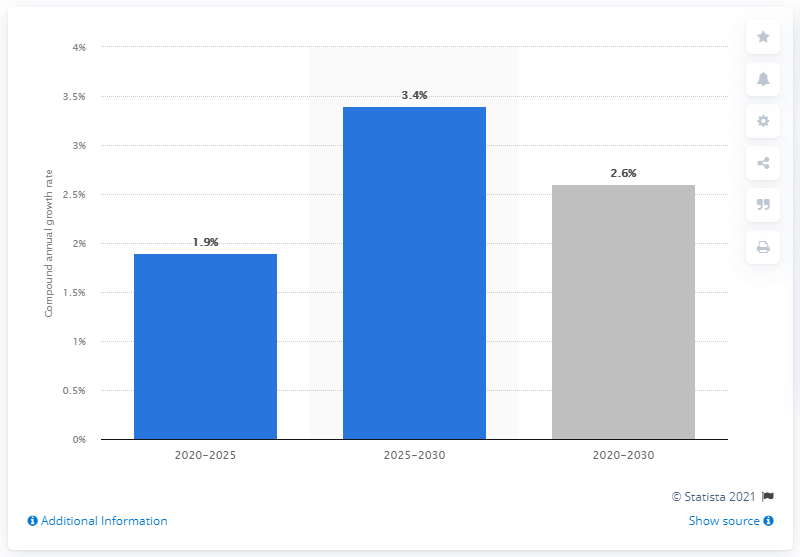Mention a couple of crucial points in this snapshot. The Latin American aircraft maintenance, repair, and overhaul (MRO) market is expected to grow at a rate of 1.9% annually between 2020 and 2025. 